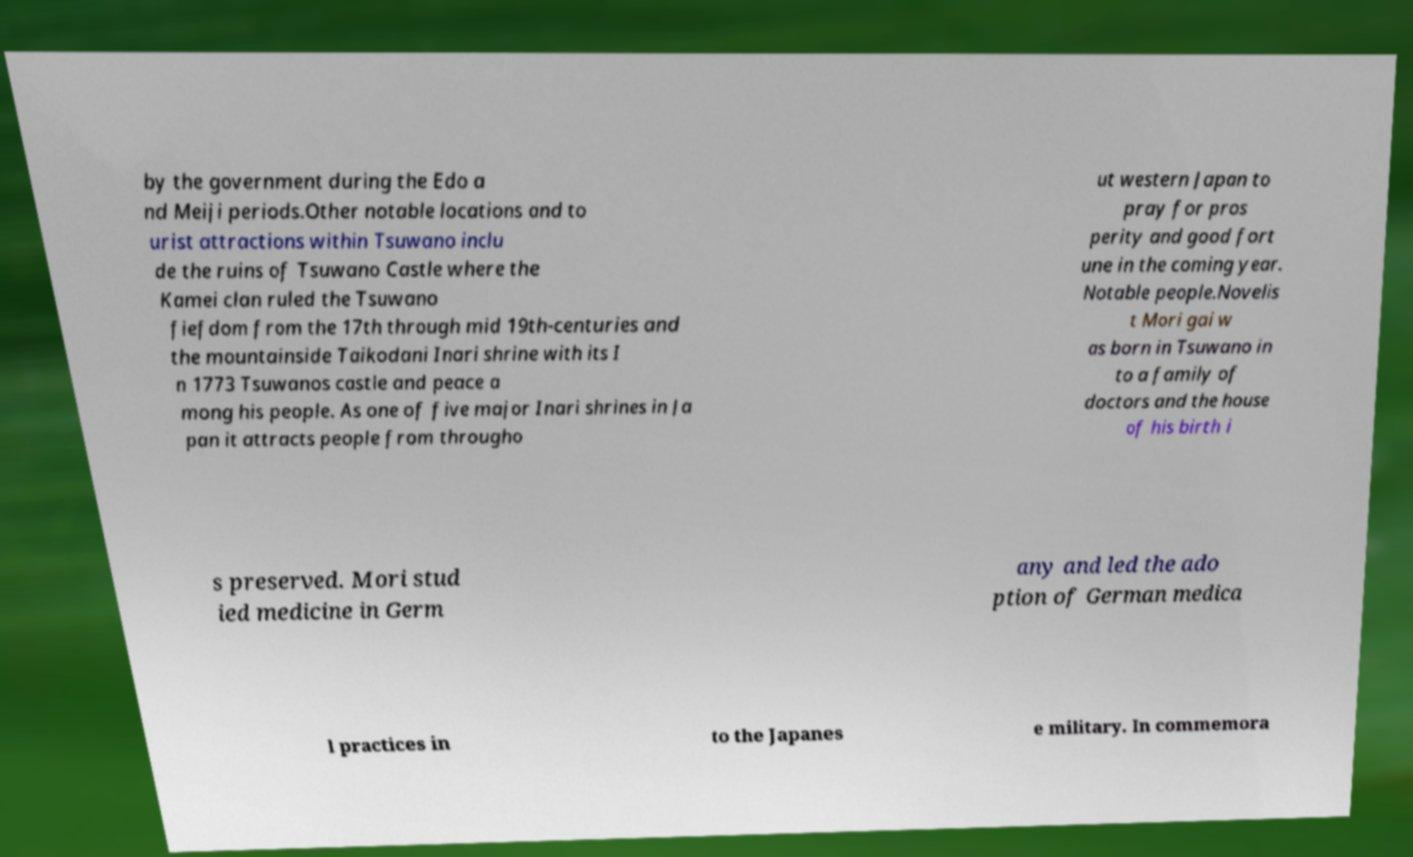There's text embedded in this image that I need extracted. Can you transcribe it verbatim? by the government during the Edo a nd Meiji periods.Other notable locations and to urist attractions within Tsuwano inclu de the ruins of Tsuwano Castle where the Kamei clan ruled the Tsuwano fiefdom from the 17th through mid 19th-centuries and the mountainside Taikodani Inari shrine with its I n 1773 Tsuwanos castle and peace a mong his people. As one of five major Inari shrines in Ja pan it attracts people from througho ut western Japan to pray for pros perity and good fort une in the coming year. Notable people.Novelis t Mori gai w as born in Tsuwano in to a family of doctors and the house of his birth i s preserved. Mori stud ied medicine in Germ any and led the ado ption of German medica l practices in to the Japanes e military. In commemora 